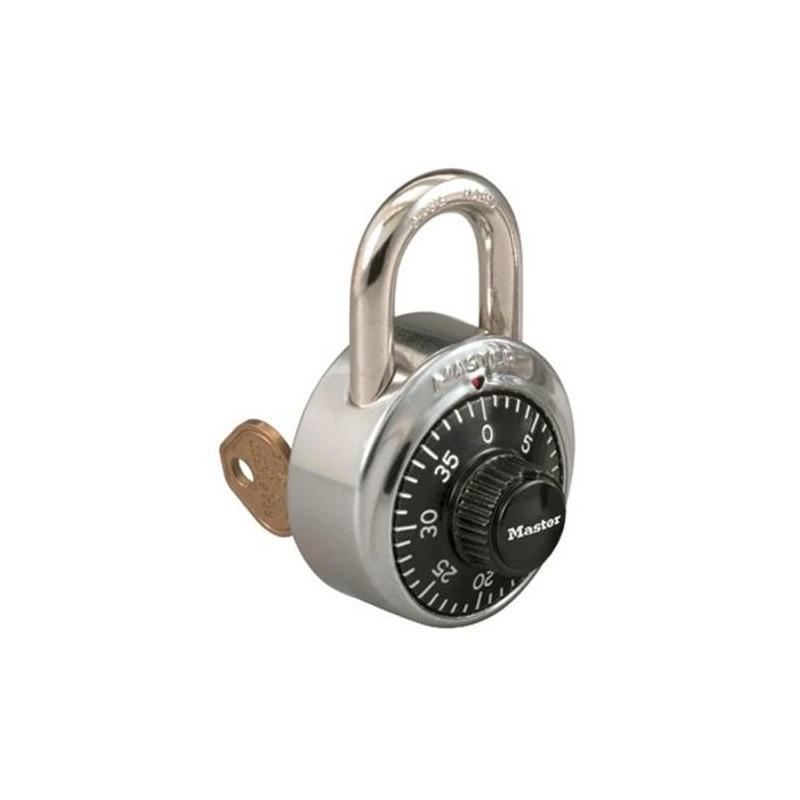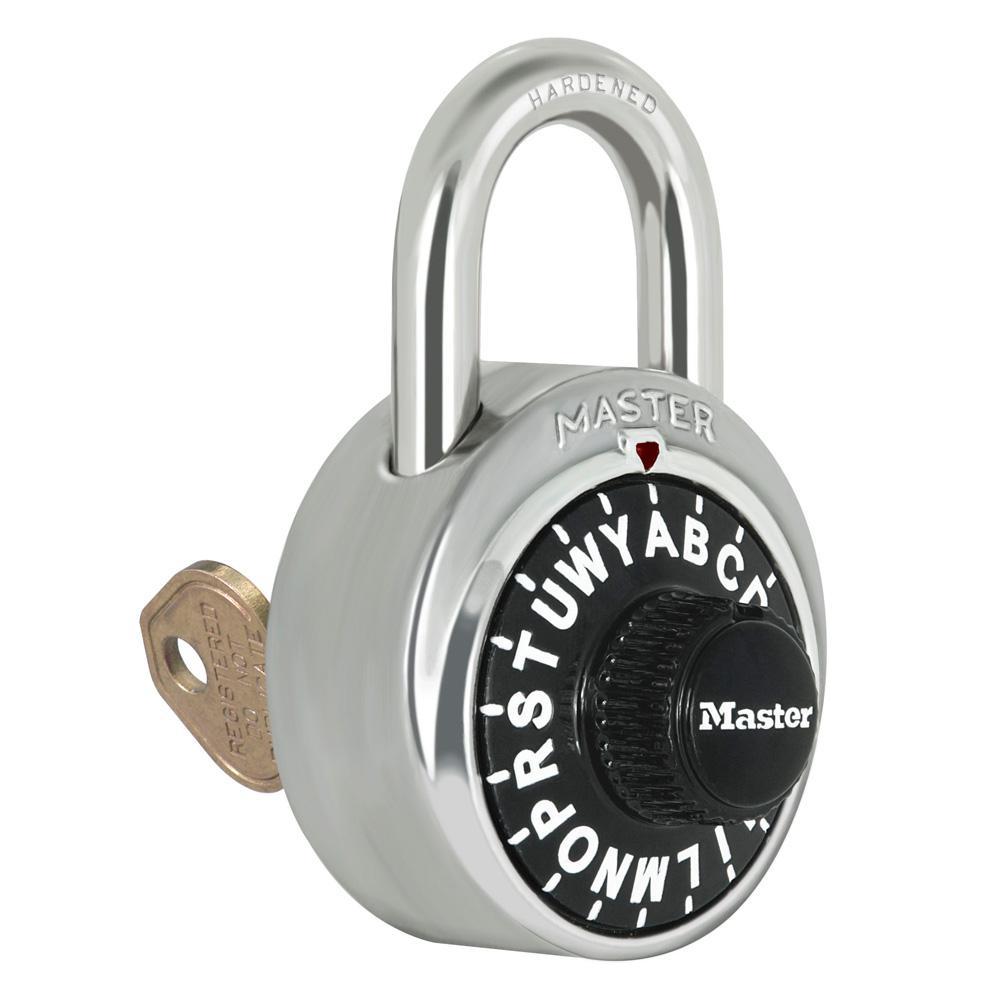The first image is the image on the left, the second image is the image on the right. Examine the images to the left and right. Is the description "The lock in the left image has combination numbers on the bottom of the lock." accurate? Answer yes or no. No. The first image is the image on the left, the second image is the image on the right. Evaluate the accuracy of this statement regarding the images: "There are two locks total and they are both the same color.". Is it true? Answer yes or no. Yes. 